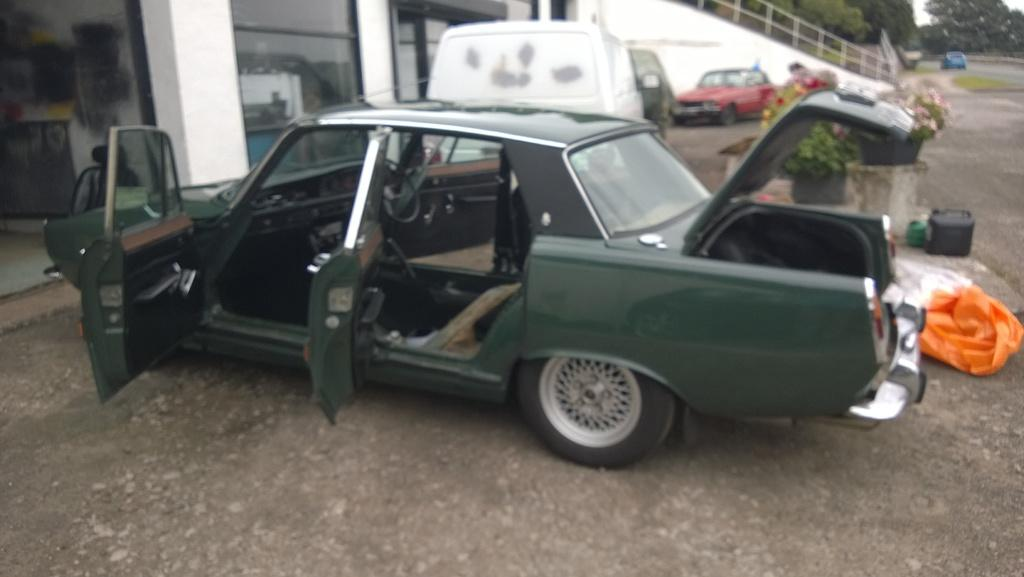What types of objects can be seen in the image? There are vehicles, glass walls, flower pots, a railing, objects, and plastic covers in the image. What is the material of the walls in the image? The walls in the image are made of glass. What can be found near the glass walls? There are flower pots near the glass walls. What is the purpose of the railing in the image? The railing in the image might be for safety or to provide support. What type of vegetation is present in the image? There are trees in the image. What time of day is it in the image, and what is the government's stance on straws? The time of day cannot be determined from the image, and the government's stance on straws is not relevant to the image. 